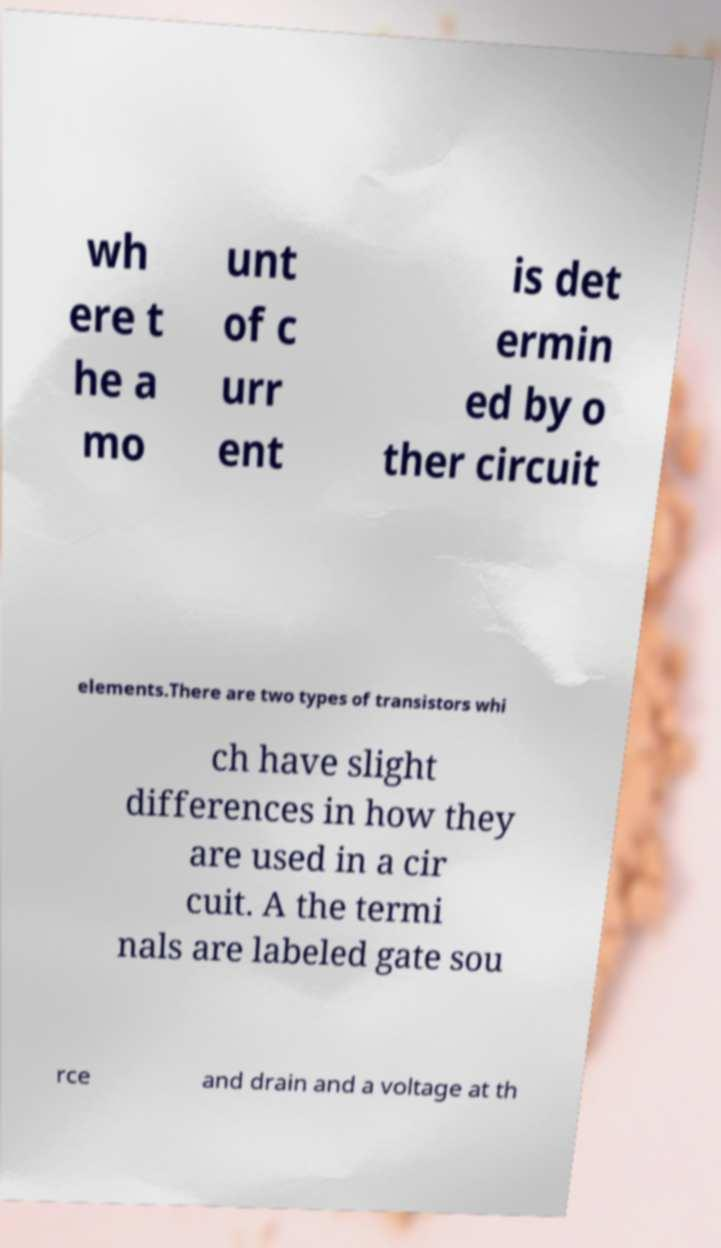Please identify and transcribe the text found in this image. wh ere t he a mo unt of c urr ent is det ermin ed by o ther circuit elements.There are two types of transistors whi ch have slight differences in how they are used in a cir cuit. A the termi nals are labeled gate sou rce and drain and a voltage at th 